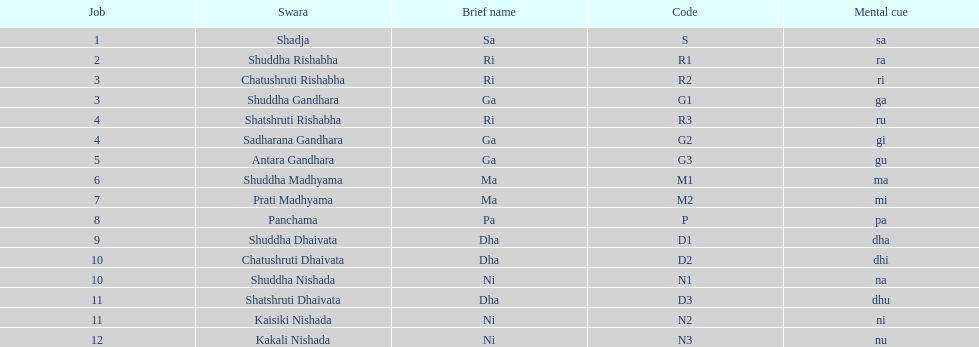Other than m1 how many notations have "1" in them? 4. 